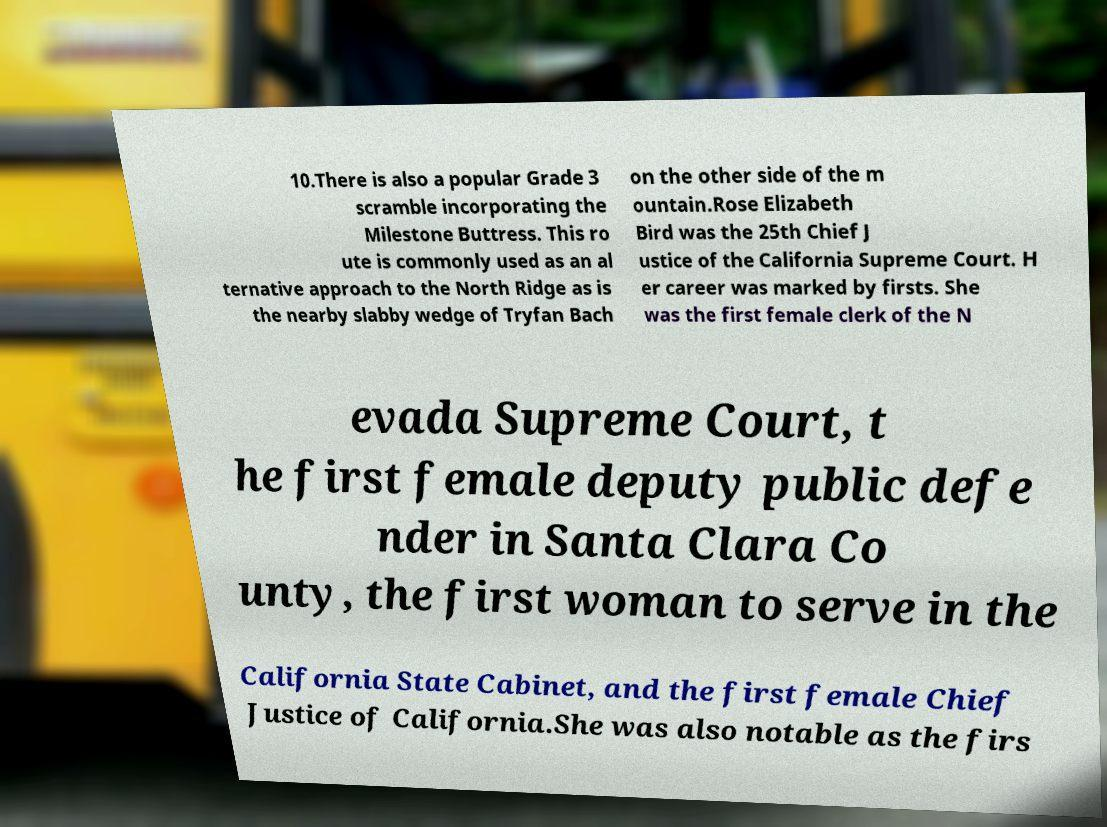What messages or text are displayed in this image? I need them in a readable, typed format. 10.There is also a popular Grade 3 scramble incorporating the Milestone Buttress. This ro ute is commonly used as an al ternative approach to the North Ridge as is the nearby slabby wedge of Tryfan Bach on the other side of the m ountain.Rose Elizabeth Bird was the 25th Chief J ustice of the California Supreme Court. H er career was marked by firsts. She was the first female clerk of the N evada Supreme Court, t he first female deputy public defe nder in Santa Clara Co unty, the first woman to serve in the California State Cabinet, and the first female Chief Justice of California.She was also notable as the firs 